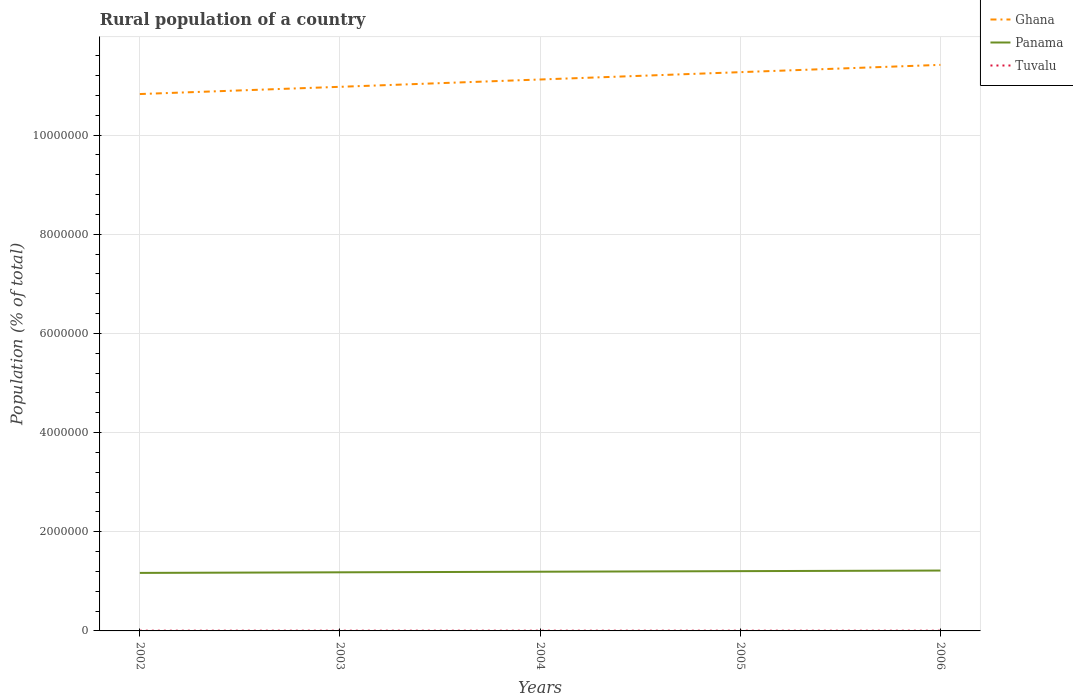How many different coloured lines are there?
Provide a short and direct response. 3. Does the line corresponding to Tuvalu intersect with the line corresponding to Ghana?
Give a very brief answer. No. Across all years, what is the maximum rural population in Ghana?
Provide a succinct answer. 1.08e+07. What is the total rural population in Tuvalu in the graph?
Your answer should be compact. 115. What is the difference between the highest and the second highest rural population in Ghana?
Offer a terse response. 5.89e+05. What is the difference between the highest and the lowest rural population in Tuvalu?
Your answer should be compact. 3. How many lines are there?
Your answer should be compact. 3. What is the difference between two consecutive major ticks on the Y-axis?
Your answer should be very brief. 2.00e+06. Does the graph contain any zero values?
Your answer should be compact. No. Where does the legend appear in the graph?
Your answer should be very brief. Top right. How many legend labels are there?
Provide a short and direct response. 3. How are the legend labels stacked?
Provide a short and direct response. Vertical. What is the title of the graph?
Make the answer very short. Rural population of a country. What is the label or title of the Y-axis?
Give a very brief answer. Population (% of total). What is the Population (% of total) of Ghana in 2002?
Make the answer very short. 1.08e+07. What is the Population (% of total) of Panama in 2002?
Make the answer very short. 1.17e+06. What is the Population (% of total) of Tuvalu in 2002?
Provide a succinct answer. 5066. What is the Population (% of total) in Ghana in 2003?
Ensure brevity in your answer.  1.10e+07. What is the Population (% of total) in Panama in 2003?
Make the answer very short. 1.18e+06. What is the Population (% of total) of Tuvalu in 2003?
Your answer should be very brief. 5020. What is the Population (% of total) of Ghana in 2004?
Offer a very short reply. 1.11e+07. What is the Population (% of total) in Panama in 2004?
Ensure brevity in your answer.  1.19e+06. What is the Population (% of total) of Tuvalu in 2004?
Give a very brief answer. 4951. What is the Population (% of total) in Ghana in 2005?
Provide a succinct answer. 1.13e+07. What is the Population (% of total) of Panama in 2005?
Your answer should be very brief. 1.21e+06. What is the Population (% of total) of Tuvalu in 2005?
Give a very brief answer. 4876. What is the Population (% of total) of Ghana in 2006?
Make the answer very short. 1.14e+07. What is the Population (% of total) in Panama in 2006?
Ensure brevity in your answer.  1.22e+06. What is the Population (% of total) of Tuvalu in 2006?
Your answer should be very brief. 4796. Across all years, what is the maximum Population (% of total) of Ghana?
Your response must be concise. 1.14e+07. Across all years, what is the maximum Population (% of total) of Panama?
Your answer should be compact. 1.22e+06. Across all years, what is the maximum Population (% of total) of Tuvalu?
Give a very brief answer. 5066. Across all years, what is the minimum Population (% of total) in Ghana?
Your answer should be compact. 1.08e+07. Across all years, what is the minimum Population (% of total) in Panama?
Your answer should be very brief. 1.17e+06. Across all years, what is the minimum Population (% of total) in Tuvalu?
Your answer should be very brief. 4796. What is the total Population (% of total) in Ghana in the graph?
Provide a short and direct response. 5.56e+07. What is the total Population (% of total) in Panama in the graph?
Provide a short and direct response. 5.97e+06. What is the total Population (% of total) of Tuvalu in the graph?
Provide a succinct answer. 2.47e+04. What is the difference between the Population (% of total) in Ghana in 2002 and that in 2003?
Your response must be concise. -1.46e+05. What is the difference between the Population (% of total) of Panama in 2002 and that in 2003?
Ensure brevity in your answer.  -1.21e+04. What is the difference between the Population (% of total) in Tuvalu in 2002 and that in 2003?
Your answer should be very brief. 46. What is the difference between the Population (% of total) in Ghana in 2002 and that in 2004?
Offer a very short reply. -2.93e+05. What is the difference between the Population (% of total) of Panama in 2002 and that in 2004?
Your answer should be very brief. -2.39e+04. What is the difference between the Population (% of total) in Tuvalu in 2002 and that in 2004?
Make the answer very short. 115. What is the difference between the Population (% of total) in Ghana in 2002 and that in 2005?
Your answer should be very brief. -4.41e+05. What is the difference between the Population (% of total) in Panama in 2002 and that in 2005?
Provide a succinct answer. -3.58e+04. What is the difference between the Population (% of total) of Tuvalu in 2002 and that in 2005?
Give a very brief answer. 190. What is the difference between the Population (% of total) in Ghana in 2002 and that in 2006?
Your response must be concise. -5.89e+05. What is the difference between the Population (% of total) of Panama in 2002 and that in 2006?
Give a very brief answer. -4.75e+04. What is the difference between the Population (% of total) in Tuvalu in 2002 and that in 2006?
Keep it short and to the point. 270. What is the difference between the Population (% of total) of Ghana in 2003 and that in 2004?
Offer a terse response. -1.48e+05. What is the difference between the Population (% of total) of Panama in 2003 and that in 2004?
Provide a succinct answer. -1.19e+04. What is the difference between the Population (% of total) in Ghana in 2003 and that in 2005?
Offer a very short reply. -2.96e+05. What is the difference between the Population (% of total) of Panama in 2003 and that in 2005?
Your answer should be compact. -2.37e+04. What is the difference between the Population (% of total) in Tuvalu in 2003 and that in 2005?
Offer a terse response. 144. What is the difference between the Population (% of total) of Ghana in 2003 and that in 2006?
Your answer should be compact. -4.43e+05. What is the difference between the Population (% of total) of Panama in 2003 and that in 2006?
Ensure brevity in your answer.  -3.54e+04. What is the difference between the Population (% of total) of Tuvalu in 2003 and that in 2006?
Provide a short and direct response. 224. What is the difference between the Population (% of total) in Ghana in 2004 and that in 2005?
Keep it short and to the point. -1.48e+05. What is the difference between the Population (% of total) of Panama in 2004 and that in 2005?
Your answer should be very brief. -1.18e+04. What is the difference between the Population (% of total) in Tuvalu in 2004 and that in 2005?
Keep it short and to the point. 75. What is the difference between the Population (% of total) in Ghana in 2004 and that in 2006?
Your answer should be very brief. -2.95e+05. What is the difference between the Population (% of total) in Panama in 2004 and that in 2006?
Provide a succinct answer. -2.35e+04. What is the difference between the Population (% of total) in Tuvalu in 2004 and that in 2006?
Give a very brief answer. 155. What is the difference between the Population (% of total) of Ghana in 2005 and that in 2006?
Give a very brief answer. -1.47e+05. What is the difference between the Population (% of total) in Panama in 2005 and that in 2006?
Provide a short and direct response. -1.17e+04. What is the difference between the Population (% of total) in Ghana in 2002 and the Population (% of total) in Panama in 2003?
Your answer should be very brief. 9.65e+06. What is the difference between the Population (% of total) in Ghana in 2002 and the Population (% of total) in Tuvalu in 2003?
Offer a very short reply. 1.08e+07. What is the difference between the Population (% of total) of Panama in 2002 and the Population (% of total) of Tuvalu in 2003?
Offer a very short reply. 1.17e+06. What is the difference between the Population (% of total) in Ghana in 2002 and the Population (% of total) in Panama in 2004?
Offer a terse response. 9.63e+06. What is the difference between the Population (% of total) of Ghana in 2002 and the Population (% of total) of Tuvalu in 2004?
Your response must be concise. 1.08e+07. What is the difference between the Population (% of total) in Panama in 2002 and the Population (% of total) in Tuvalu in 2004?
Offer a very short reply. 1.17e+06. What is the difference between the Population (% of total) of Ghana in 2002 and the Population (% of total) of Panama in 2005?
Provide a succinct answer. 9.62e+06. What is the difference between the Population (% of total) of Ghana in 2002 and the Population (% of total) of Tuvalu in 2005?
Offer a terse response. 1.08e+07. What is the difference between the Population (% of total) of Panama in 2002 and the Population (% of total) of Tuvalu in 2005?
Give a very brief answer. 1.17e+06. What is the difference between the Population (% of total) of Ghana in 2002 and the Population (% of total) of Panama in 2006?
Provide a short and direct response. 9.61e+06. What is the difference between the Population (% of total) in Ghana in 2002 and the Population (% of total) in Tuvalu in 2006?
Your answer should be very brief. 1.08e+07. What is the difference between the Population (% of total) of Panama in 2002 and the Population (% of total) of Tuvalu in 2006?
Your answer should be very brief. 1.17e+06. What is the difference between the Population (% of total) in Ghana in 2003 and the Population (% of total) in Panama in 2004?
Ensure brevity in your answer.  9.78e+06. What is the difference between the Population (% of total) in Ghana in 2003 and the Population (% of total) in Tuvalu in 2004?
Offer a terse response. 1.10e+07. What is the difference between the Population (% of total) of Panama in 2003 and the Population (% of total) of Tuvalu in 2004?
Your answer should be very brief. 1.18e+06. What is the difference between the Population (% of total) in Ghana in 2003 and the Population (% of total) in Panama in 2005?
Your answer should be compact. 9.77e+06. What is the difference between the Population (% of total) in Ghana in 2003 and the Population (% of total) in Tuvalu in 2005?
Make the answer very short. 1.10e+07. What is the difference between the Population (% of total) in Panama in 2003 and the Population (% of total) in Tuvalu in 2005?
Ensure brevity in your answer.  1.18e+06. What is the difference between the Population (% of total) in Ghana in 2003 and the Population (% of total) in Panama in 2006?
Provide a succinct answer. 9.76e+06. What is the difference between the Population (% of total) of Ghana in 2003 and the Population (% of total) of Tuvalu in 2006?
Ensure brevity in your answer.  1.10e+07. What is the difference between the Population (% of total) in Panama in 2003 and the Population (% of total) in Tuvalu in 2006?
Give a very brief answer. 1.18e+06. What is the difference between the Population (% of total) in Ghana in 2004 and the Population (% of total) in Panama in 2005?
Ensure brevity in your answer.  9.92e+06. What is the difference between the Population (% of total) of Ghana in 2004 and the Population (% of total) of Tuvalu in 2005?
Your response must be concise. 1.11e+07. What is the difference between the Population (% of total) of Panama in 2004 and the Population (% of total) of Tuvalu in 2005?
Offer a very short reply. 1.19e+06. What is the difference between the Population (% of total) in Ghana in 2004 and the Population (% of total) in Panama in 2006?
Your answer should be very brief. 9.90e+06. What is the difference between the Population (% of total) in Ghana in 2004 and the Population (% of total) in Tuvalu in 2006?
Ensure brevity in your answer.  1.11e+07. What is the difference between the Population (% of total) in Panama in 2004 and the Population (% of total) in Tuvalu in 2006?
Offer a very short reply. 1.19e+06. What is the difference between the Population (% of total) of Ghana in 2005 and the Population (% of total) of Panama in 2006?
Make the answer very short. 1.01e+07. What is the difference between the Population (% of total) of Ghana in 2005 and the Population (% of total) of Tuvalu in 2006?
Your response must be concise. 1.13e+07. What is the difference between the Population (% of total) of Panama in 2005 and the Population (% of total) of Tuvalu in 2006?
Your answer should be compact. 1.20e+06. What is the average Population (% of total) in Ghana per year?
Offer a very short reply. 1.11e+07. What is the average Population (% of total) of Panama per year?
Your response must be concise. 1.19e+06. What is the average Population (% of total) in Tuvalu per year?
Provide a succinct answer. 4941.8. In the year 2002, what is the difference between the Population (% of total) of Ghana and Population (% of total) of Panama?
Offer a very short reply. 9.66e+06. In the year 2002, what is the difference between the Population (% of total) in Ghana and Population (% of total) in Tuvalu?
Provide a succinct answer. 1.08e+07. In the year 2002, what is the difference between the Population (% of total) of Panama and Population (% of total) of Tuvalu?
Offer a very short reply. 1.17e+06. In the year 2003, what is the difference between the Population (% of total) in Ghana and Population (% of total) in Panama?
Ensure brevity in your answer.  9.79e+06. In the year 2003, what is the difference between the Population (% of total) in Ghana and Population (% of total) in Tuvalu?
Your answer should be compact. 1.10e+07. In the year 2003, what is the difference between the Population (% of total) in Panama and Population (% of total) in Tuvalu?
Offer a very short reply. 1.18e+06. In the year 2004, what is the difference between the Population (% of total) of Ghana and Population (% of total) of Panama?
Give a very brief answer. 9.93e+06. In the year 2004, what is the difference between the Population (% of total) of Ghana and Population (% of total) of Tuvalu?
Your answer should be very brief. 1.11e+07. In the year 2004, what is the difference between the Population (% of total) of Panama and Population (% of total) of Tuvalu?
Your answer should be compact. 1.19e+06. In the year 2005, what is the difference between the Population (% of total) of Ghana and Population (% of total) of Panama?
Your answer should be compact. 1.01e+07. In the year 2005, what is the difference between the Population (% of total) of Ghana and Population (% of total) of Tuvalu?
Give a very brief answer. 1.13e+07. In the year 2005, what is the difference between the Population (% of total) of Panama and Population (% of total) of Tuvalu?
Make the answer very short. 1.20e+06. In the year 2006, what is the difference between the Population (% of total) of Ghana and Population (% of total) of Panama?
Give a very brief answer. 1.02e+07. In the year 2006, what is the difference between the Population (% of total) in Ghana and Population (% of total) in Tuvalu?
Provide a short and direct response. 1.14e+07. In the year 2006, what is the difference between the Population (% of total) in Panama and Population (% of total) in Tuvalu?
Provide a succinct answer. 1.21e+06. What is the ratio of the Population (% of total) in Ghana in 2002 to that in 2003?
Your answer should be compact. 0.99. What is the ratio of the Population (% of total) in Tuvalu in 2002 to that in 2003?
Your answer should be very brief. 1.01. What is the ratio of the Population (% of total) of Ghana in 2002 to that in 2004?
Offer a very short reply. 0.97. What is the ratio of the Population (% of total) of Panama in 2002 to that in 2004?
Make the answer very short. 0.98. What is the ratio of the Population (% of total) of Tuvalu in 2002 to that in 2004?
Your answer should be compact. 1.02. What is the ratio of the Population (% of total) of Ghana in 2002 to that in 2005?
Ensure brevity in your answer.  0.96. What is the ratio of the Population (% of total) of Panama in 2002 to that in 2005?
Offer a terse response. 0.97. What is the ratio of the Population (% of total) in Tuvalu in 2002 to that in 2005?
Ensure brevity in your answer.  1.04. What is the ratio of the Population (% of total) of Ghana in 2002 to that in 2006?
Your answer should be compact. 0.95. What is the ratio of the Population (% of total) in Tuvalu in 2002 to that in 2006?
Your answer should be very brief. 1.06. What is the ratio of the Population (% of total) of Ghana in 2003 to that in 2004?
Your answer should be very brief. 0.99. What is the ratio of the Population (% of total) of Panama in 2003 to that in 2004?
Offer a terse response. 0.99. What is the ratio of the Population (% of total) in Tuvalu in 2003 to that in 2004?
Ensure brevity in your answer.  1.01. What is the ratio of the Population (% of total) in Ghana in 2003 to that in 2005?
Give a very brief answer. 0.97. What is the ratio of the Population (% of total) in Panama in 2003 to that in 2005?
Offer a terse response. 0.98. What is the ratio of the Population (% of total) in Tuvalu in 2003 to that in 2005?
Give a very brief answer. 1.03. What is the ratio of the Population (% of total) of Ghana in 2003 to that in 2006?
Give a very brief answer. 0.96. What is the ratio of the Population (% of total) in Panama in 2003 to that in 2006?
Ensure brevity in your answer.  0.97. What is the ratio of the Population (% of total) of Tuvalu in 2003 to that in 2006?
Provide a succinct answer. 1.05. What is the ratio of the Population (% of total) of Ghana in 2004 to that in 2005?
Give a very brief answer. 0.99. What is the ratio of the Population (% of total) in Panama in 2004 to that in 2005?
Provide a short and direct response. 0.99. What is the ratio of the Population (% of total) of Tuvalu in 2004 to that in 2005?
Your response must be concise. 1.02. What is the ratio of the Population (% of total) in Ghana in 2004 to that in 2006?
Offer a terse response. 0.97. What is the ratio of the Population (% of total) of Panama in 2004 to that in 2006?
Give a very brief answer. 0.98. What is the ratio of the Population (% of total) in Tuvalu in 2004 to that in 2006?
Keep it short and to the point. 1.03. What is the ratio of the Population (% of total) of Ghana in 2005 to that in 2006?
Your answer should be very brief. 0.99. What is the ratio of the Population (% of total) in Panama in 2005 to that in 2006?
Offer a terse response. 0.99. What is the ratio of the Population (% of total) of Tuvalu in 2005 to that in 2006?
Your answer should be compact. 1.02. What is the difference between the highest and the second highest Population (% of total) of Ghana?
Your response must be concise. 1.47e+05. What is the difference between the highest and the second highest Population (% of total) of Panama?
Ensure brevity in your answer.  1.17e+04. What is the difference between the highest and the second highest Population (% of total) of Tuvalu?
Make the answer very short. 46. What is the difference between the highest and the lowest Population (% of total) of Ghana?
Ensure brevity in your answer.  5.89e+05. What is the difference between the highest and the lowest Population (% of total) in Panama?
Your answer should be very brief. 4.75e+04. What is the difference between the highest and the lowest Population (% of total) in Tuvalu?
Offer a terse response. 270. 